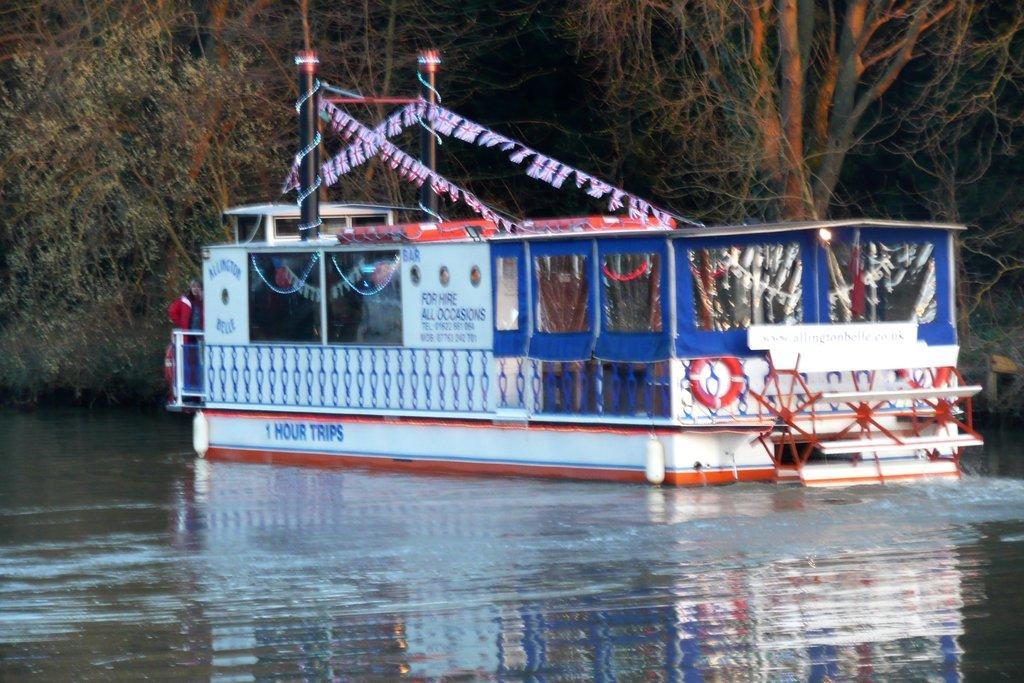Could you give a brief overview of what you see in this image? There is a boat on the water. On the boat there are decorations and something written on that. In the back there are trees. 